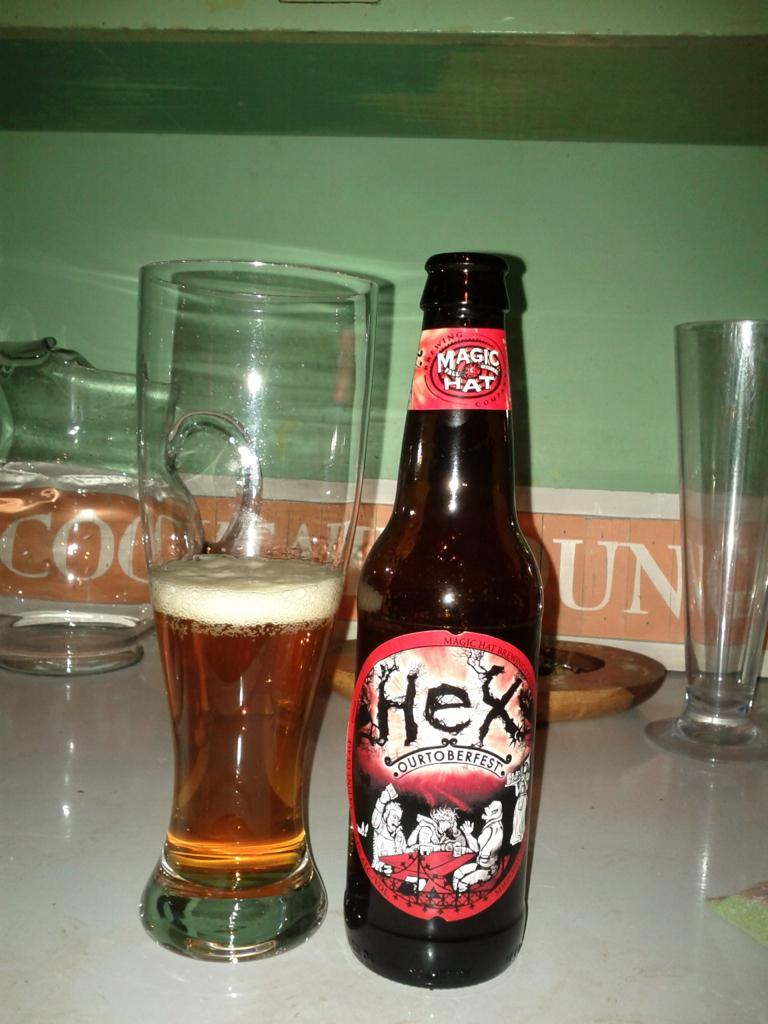<image>
Create a compact narrative representing the image presented. A bottle of Hex Ourtoberfest beer from Magic Hat Brewing next to half a glass of beer. 